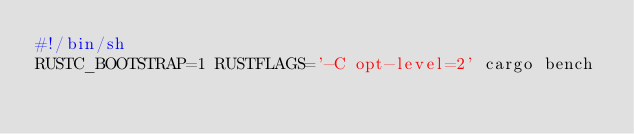Convert code to text. <code><loc_0><loc_0><loc_500><loc_500><_Bash_>#!/bin/sh
RUSTC_BOOTSTRAP=1 RUSTFLAGS='-C opt-level=2' cargo bench
</code> 